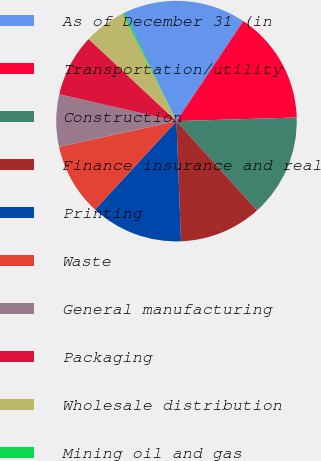Convert chart to OTSL. <chart><loc_0><loc_0><loc_500><loc_500><pie_chart><fcel>As of December 31 (in<fcel>Transportation/utility<fcel>Construction<fcel>Finance insurance and real<fcel>Printing<fcel>Waste<fcel>General manufacturing<fcel>Packaging<fcel>Wholesale distribution<fcel>Mining oil and gas<nl><fcel>16.51%<fcel>15.15%<fcel>13.8%<fcel>11.08%<fcel>12.44%<fcel>9.73%<fcel>7.02%<fcel>8.37%<fcel>5.66%<fcel>0.24%<nl></chart> 